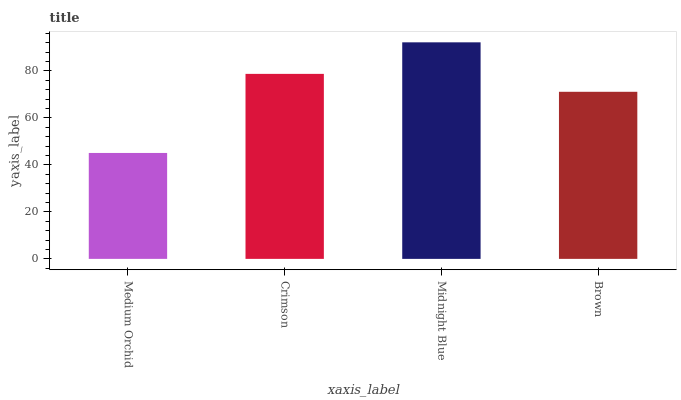Is Medium Orchid the minimum?
Answer yes or no. Yes. Is Midnight Blue the maximum?
Answer yes or no. Yes. Is Crimson the minimum?
Answer yes or no. No. Is Crimson the maximum?
Answer yes or no. No. Is Crimson greater than Medium Orchid?
Answer yes or no. Yes. Is Medium Orchid less than Crimson?
Answer yes or no. Yes. Is Medium Orchid greater than Crimson?
Answer yes or no. No. Is Crimson less than Medium Orchid?
Answer yes or no. No. Is Crimson the high median?
Answer yes or no. Yes. Is Brown the low median?
Answer yes or no. Yes. Is Midnight Blue the high median?
Answer yes or no. No. Is Medium Orchid the low median?
Answer yes or no. No. 